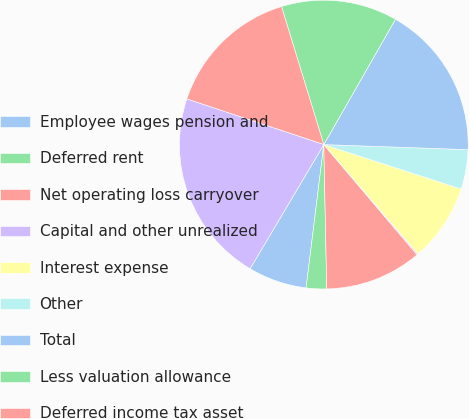Convert chart. <chart><loc_0><loc_0><loc_500><loc_500><pie_chart><fcel>Employee wages pension and<fcel>Deferred rent<fcel>Net operating loss carryover<fcel>Capital and other unrealized<fcel>Interest expense<fcel>Other<fcel>Total<fcel>Less valuation allowance<fcel>Deferred income tax asset<fcel>Fixed assets and intangible<nl><fcel>6.57%<fcel>2.28%<fcel>10.86%<fcel>0.13%<fcel>8.71%<fcel>4.42%<fcel>17.29%<fcel>13.0%<fcel>15.15%<fcel>21.59%<nl></chart> 